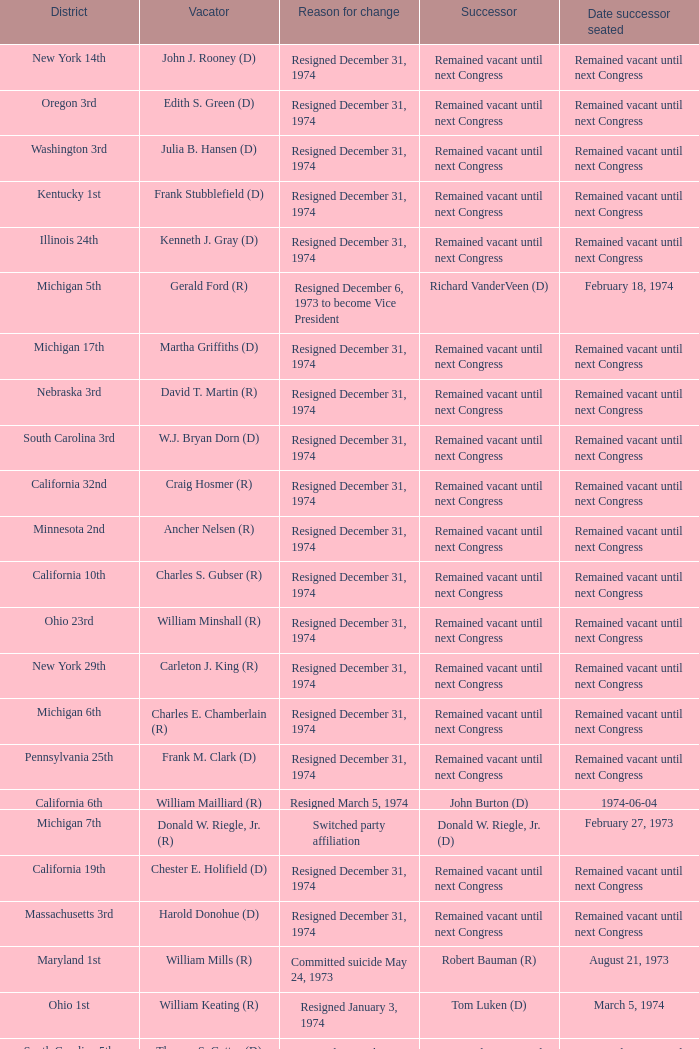What was the district when the rationale for change expired on january 1, 1974? California 13th. 